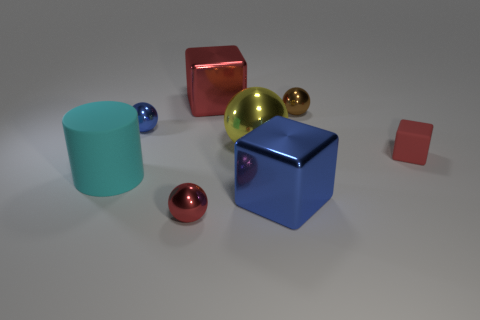Can you describe the setting of these objects? Certainly! The objects are arranged on a plain, lightly textured surface that appears to be indoors. The lighting suggests an ambient source, perhaps overhead, casting soft shadows beneath each object. The background is neutral and nondescript, which helps bring focus to the objects themselves. 